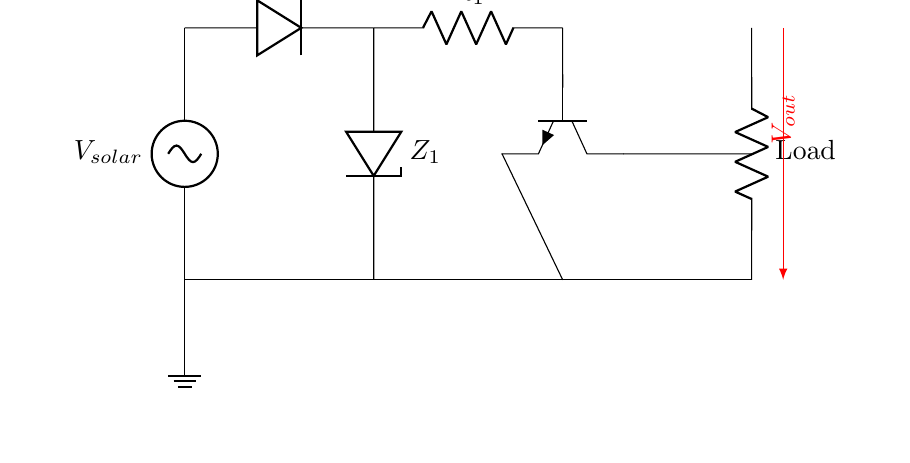What is the function of the diode in this circuit? The diode allows current to flow in one direction only, preventing reverse current that could damage the solar panel.
Answer: Current direction control What component is used for voltage regulation? The Zener diode is used as a voltage regulator that clamps the voltage to a specific level, protecting sensitive components.
Answer: Zener diode What does the load represent in this circuit? The load represents the device or application that consumes the electrical energy generated by the solar panel, connected at the output.
Answer: Electrical load How many resistors are shown in the circuit? There is only one resistor labeled R1 in the circuit diagram as part of the voltage regulation.
Answer: One What is the role of the transistor in this circuit? The transistor acts as a switch or amplifier that helps control the output voltage based on the input from the solar panel and is crucial for achieving stable operation.
Answer: Switch or amplifier What is the output voltage noted in the circuit? The output voltage is represented as Vout, indicating the voltage supplied to the load, which is derived from the solar panel through the protection circuitry.
Answer: Vout What happens when the voltage exceeds the Zener diode rating? When the voltage exceeds the Zener diode rating, the diode conducts in reverse, shunting excess current to ground and protecting downstream components from overvoltage damage.
Answer: Overvoltage protection 